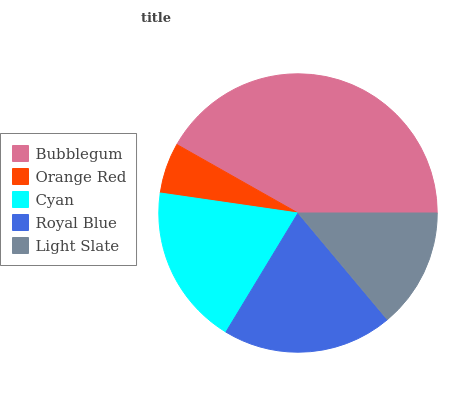Is Orange Red the minimum?
Answer yes or no. Yes. Is Bubblegum the maximum?
Answer yes or no. Yes. Is Cyan the minimum?
Answer yes or no. No. Is Cyan the maximum?
Answer yes or no. No. Is Cyan greater than Orange Red?
Answer yes or no. Yes. Is Orange Red less than Cyan?
Answer yes or no. Yes. Is Orange Red greater than Cyan?
Answer yes or no. No. Is Cyan less than Orange Red?
Answer yes or no. No. Is Cyan the high median?
Answer yes or no. Yes. Is Cyan the low median?
Answer yes or no. Yes. Is Royal Blue the high median?
Answer yes or no. No. Is Bubblegum the low median?
Answer yes or no. No. 